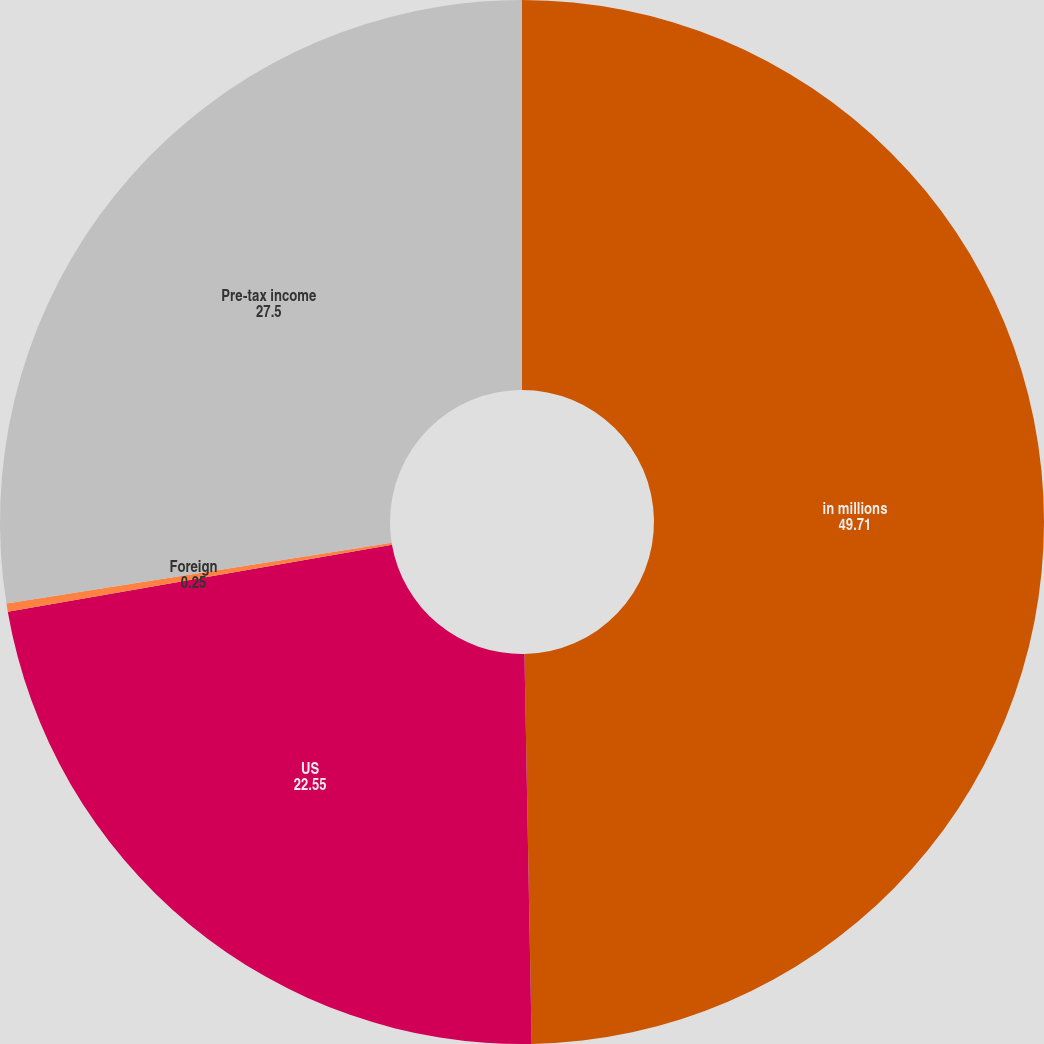Convert chart to OTSL. <chart><loc_0><loc_0><loc_500><loc_500><pie_chart><fcel>in millions<fcel>US<fcel>Foreign<fcel>Pre-tax income<nl><fcel>49.71%<fcel>22.55%<fcel>0.25%<fcel>27.5%<nl></chart> 